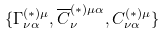<formula> <loc_0><loc_0><loc_500><loc_500>\{ \Gamma _ { \nu \alpha } ^ { ( * ) \mu } , \overline { C } _ { \nu } ^ { ( * ) \mu \alpha } , C _ { \nu \alpha } ^ { ( * ) \mu } \}</formula> 